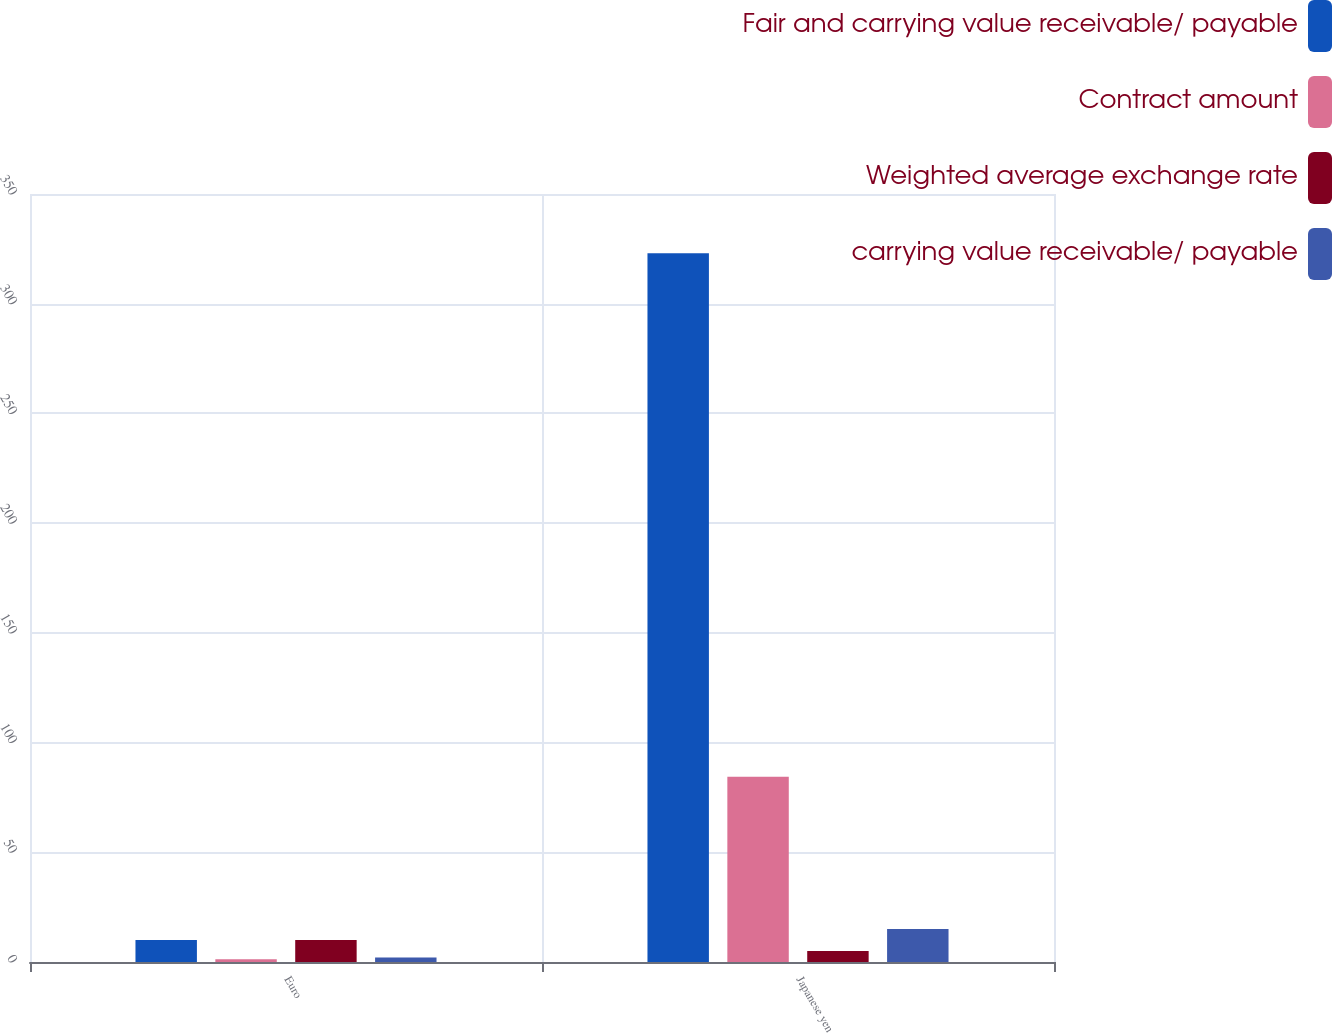Convert chart. <chart><loc_0><loc_0><loc_500><loc_500><stacked_bar_chart><ecel><fcel>Euro<fcel>Japanese yen<nl><fcel>Fair and carrying value receivable/ payable<fcel>10<fcel>323<nl><fcel>Contract amount<fcel>1.31<fcel>84.4<nl><fcel>Weighted average exchange rate<fcel>10<fcel>5<nl><fcel>carrying value receivable/ payable<fcel>2<fcel>15<nl></chart> 